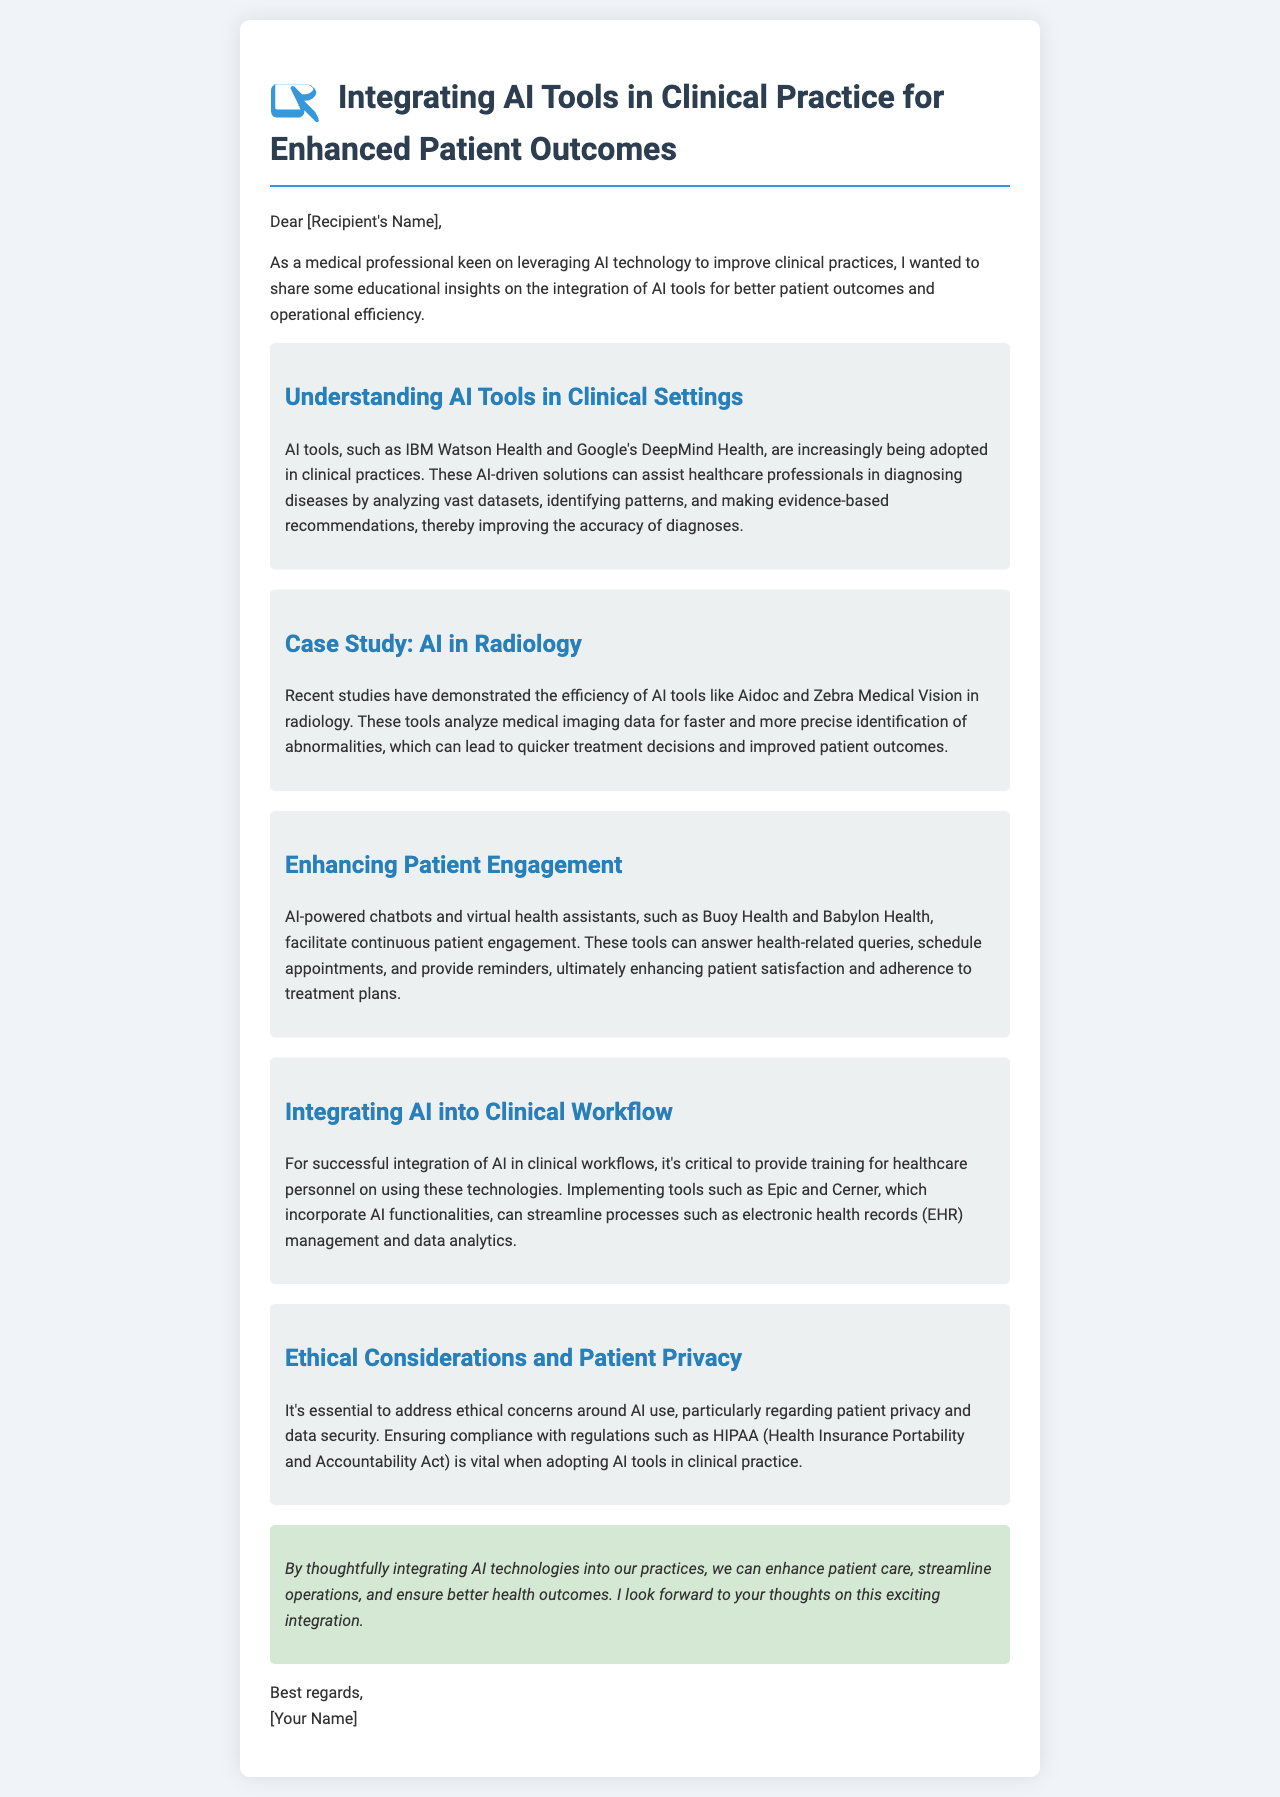What are two examples of AI tools mentioned? The document lists IBM Watson Health and Google's DeepMind Health as examples of AI tools used in clinical practice.
Answer: IBM Watson Health, Google's DeepMind Health What is a benefit of AI in radiology? AI tools like Aidoc and Zebra Medical Vision help in faster and more precise identification of abnormalities in radiology.
Answer: Faster and more precise identification What is essential for integrating AI into clinical workflows? The document states that it's critical to provide training for healthcare personnel on using AI technologies for successful integration.
Answer: Training What ethical concern is highlighted? The document emphasizes the importance of addressing patient privacy and data security concerns when using AI tools in clinical practice.
Answer: Patient privacy What types of AI-powered tools enhance patient engagement? The document refers to chatbots and virtual health assistants like Buoy Health and Babylon Health as tools that facilitate patient engagement.
Answer: Chatbots, virtual health assistants 